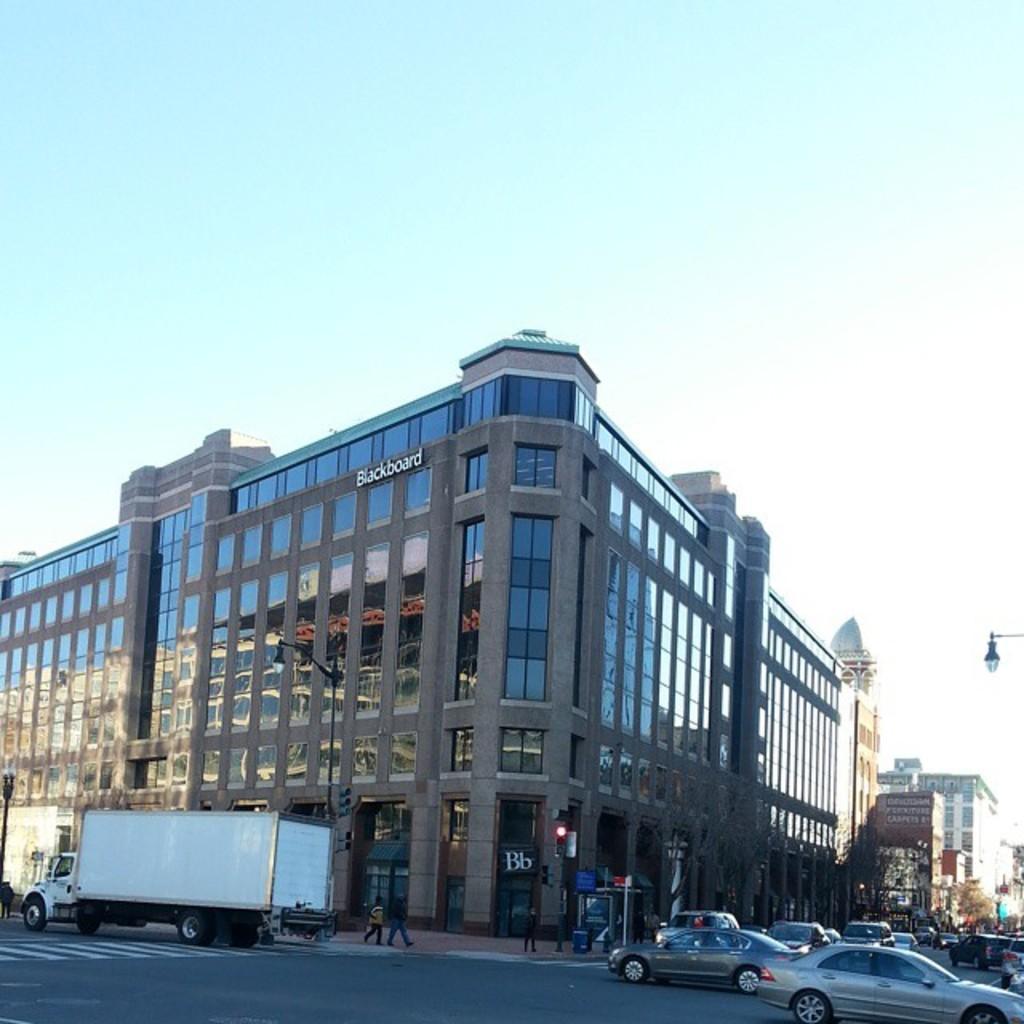Describe this image in one or two sentences. In this image I can see the many vehicles are on the road. To the side of the road I can see few people, poles, trees and there is a building. I can see some boards to the building. I can see the clouds and the sky in the back. 